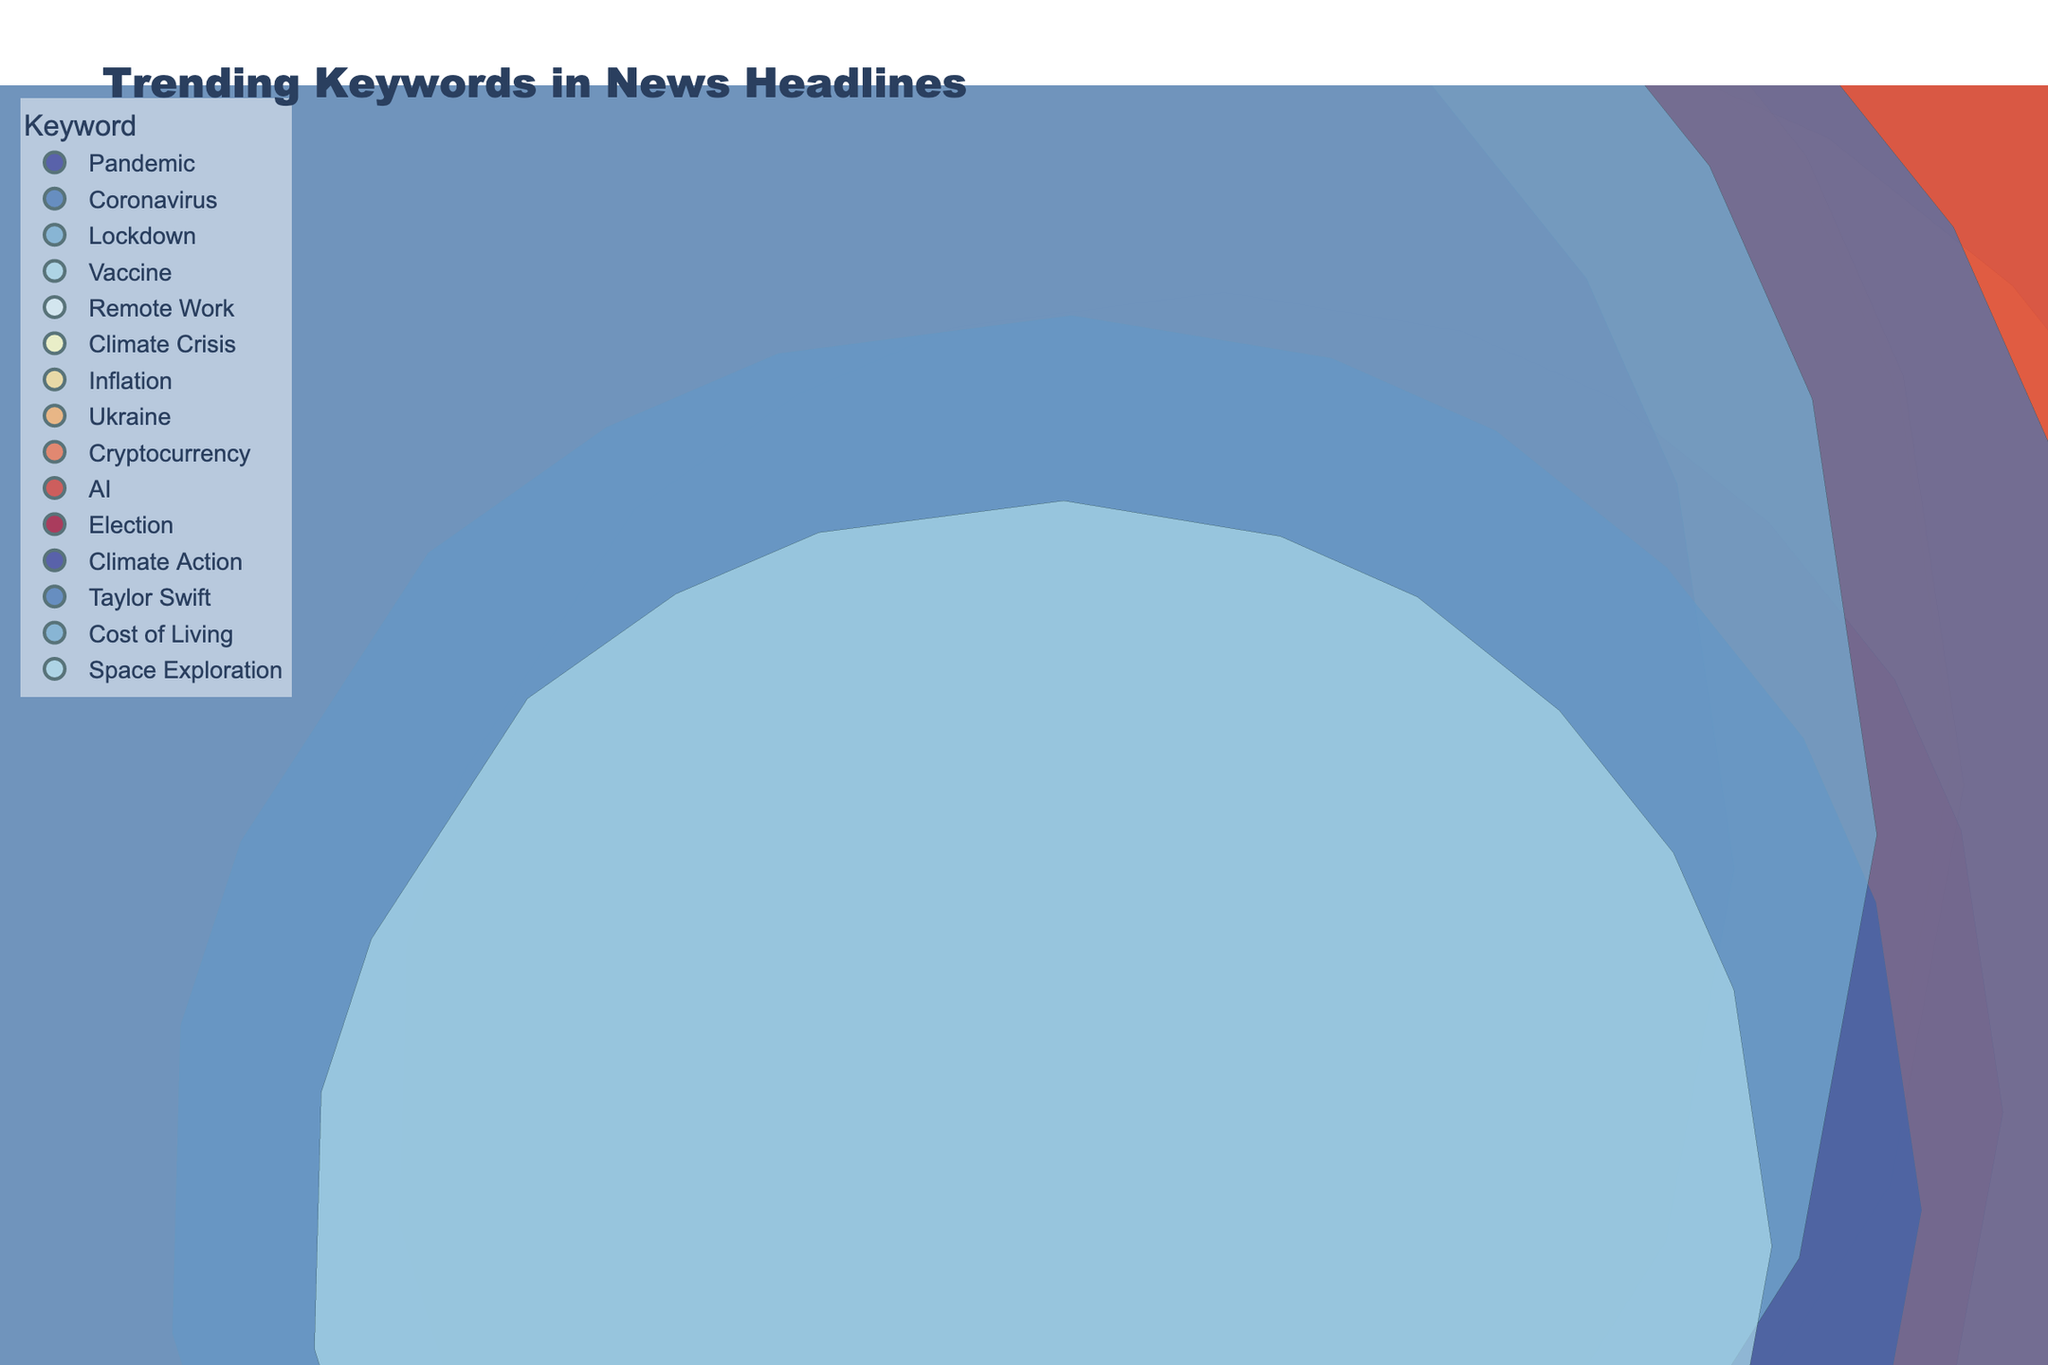What is the title of the figure? The title of the figure is written at the top of the chart.
Answer: Trending Keywords in News Headlines How many data points are represented in the figure? Each bubble in the 3D chart represents a data point. By counting the bubbles, we find there are 15 data points.
Answer: 15 Which keyword in the year 2020 has the highest frequency? Look at the 2020 keywords and compare their z-axis values (Frequency). The highest frequency is "Coronavirus" with a frequency of 120.
Answer: Coronavirus What is the average frequency of the keywords in 2021? The keywords in 2021 are "Vaccine" (110), "Remote Work" (70), and "Climate Crisis" (65). Summing these frequencies gives (110 + 70 + 65 = 245). Dividing by 3 gives an average of 245/3.
Answer: 81.67 Which media type has the highest frequency keyword in 2023? Look at the 2023 bubbles and identify the highest frequency on the z-axis. "AI" has the highest frequency of 130, which is associated with the Online media type.
Answer: Online Compare the frequency of the keyword "Pandemic" in 2020 with "AI" in 2023. Which is higher and by how much? "Pandemic" in 2020 has a frequency of 85, and "AI" in 2023 has 130. 130 - 85 = 45, thus "AI" is higher by 45.
Answer: AI, by 45 Which keyword is associated with the Broadcast media type in 2022, and what is its frequency? Identify the keyword within the 2022 year and Broadcast media type. The keyword is "Cryptocurrency" with a frequency of 55.
Answer: Cryptocurrency, 55 What is the total frequency of keywords associated with the Print media type across all years? Summing the frequencies of Print media keywords: "Pandemic" (85), "Remote Work" (70), "Inflation" (80), "Election" (75), and "Cost of Living" (85) gives 85 + 70 + 80 + 75 + 85 = 395.
Answer: 395 Which keyword has been trending in the Online media type from 2020 to 2023 and has the highest frequency? Count and compare the Online media bubbles for all years. "AI" in 2023 has the highest frequency of 130.
Answer: AI Which year has the highest total sum of keyword frequencies? Sum the frequency of keywords for each year:
2020: 85 + 120 + 95 = 300
2021: 110 + 70 + 65 = 245
2022: 80 + 105 + 55 = 240
2023: 130 + 75 + 60 + 90 + 85 + 50 = 490
2023 has the highest total of 490.
Answer: 2023 